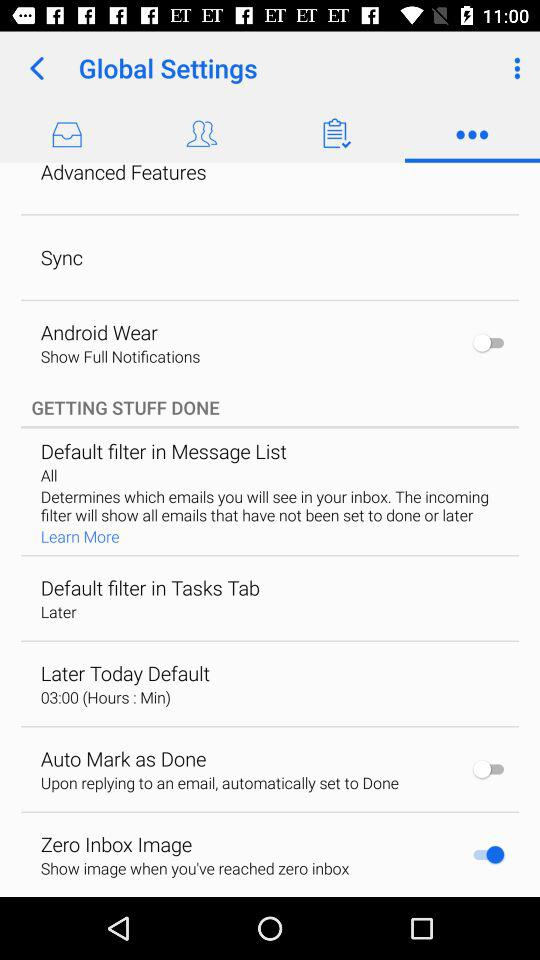What is the setting for later today default? The setting for later today default is "03:00 (Hours : Min)". 